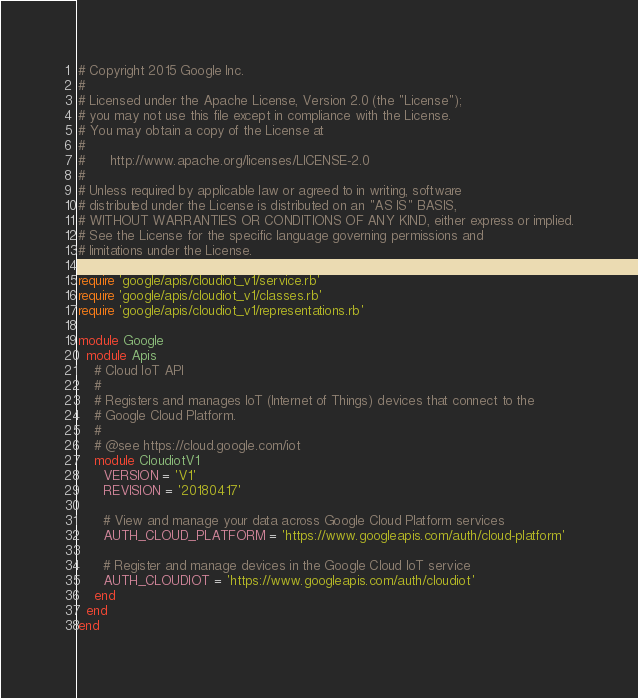Convert code to text. <code><loc_0><loc_0><loc_500><loc_500><_Ruby_># Copyright 2015 Google Inc.
#
# Licensed under the Apache License, Version 2.0 (the "License");
# you may not use this file except in compliance with the License.
# You may obtain a copy of the License at
#
#      http://www.apache.org/licenses/LICENSE-2.0
#
# Unless required by applicable law or agreed to in writing, software
# distributed under the License is distributed on an "AS IS" BASIS,
# WITHOUT WARRANTIES OR CONDITIONS OF ANY KIND, either express or implied.
# See the License for the specific language governing permissions and
# limitations under the License.

require 'google/apis/cloudiot_v1/service.rb'
require 'google/apis/cloudiot_v1/classes.rb'
require 'google/apis/cloudiot_v1/representations.rb'

module Google
  module Apis
    # Cloud IoT API
    #
    # Registers and manages IoT (Internet of Things) devices that connect to the
    # Google Cloud Platform.
    #
    # @see https://cloud.google.com/iot
    module CloudiotV1
      VERSION = 'V1'
      REVISION = '20180417'

      # View and manage your data across Google Cloud Platform services
      AUTH_CLOUD_PLATFORM = 'https://www.googleapis.com/auth/cloud-platform'

      # Register and manage devices in the Google Cloud IoT service
      AUTH_CLOUDIOT = 'https://www.googleapis.com/auth/cloudiot'
    end
  end
end
</code> 